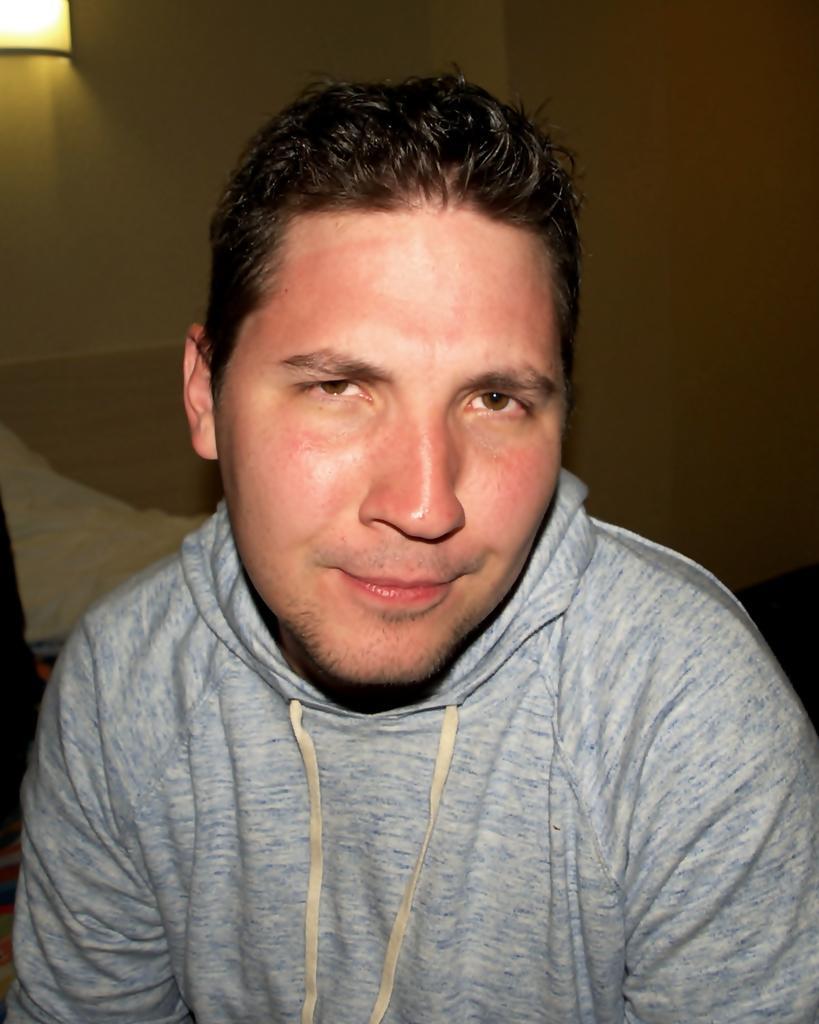Please provide a concise description of this image. In this picture there is a man. At the back there is an object and there is a light on the wall. 